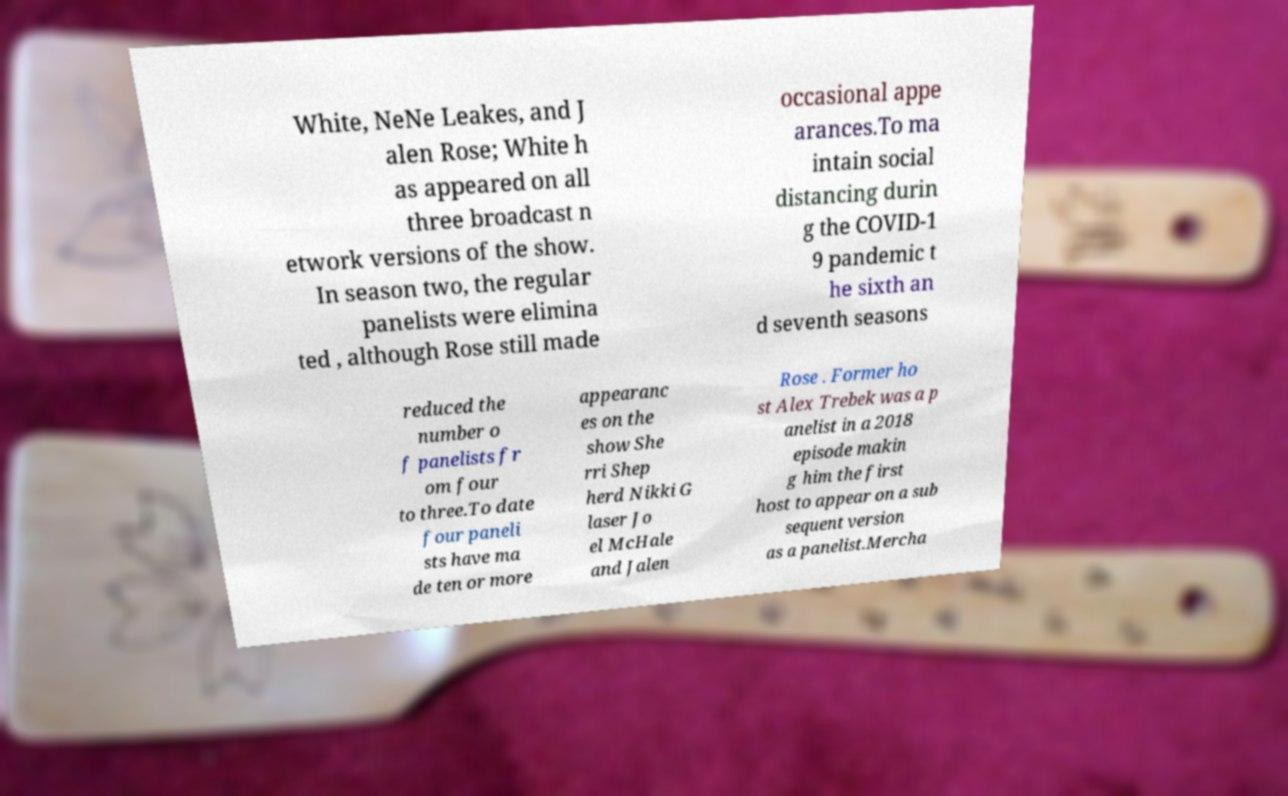Can you accurately transcribe the text from the provided image for me? White, NeNe Leakes, and J alen Rose; White h as appeared on all three broadcast n etwork versions of the show. In season two, the regular panelists were elimina ted , although Rose still made occasional appe arances.To ma intain social distancing durin g the COVID-1 9 pandemic t he sixth an d seventh seasons reduced the number o f panelists fr om four to three.To date four paneli sts have ma de ten or more appearanc es on the show She rri Shep herd Nikki G laser Jo el McHale and Jalen Rose . Former ho st Alex Trebek was a p anelist in a 2018 episode makin g him the first host to appear on a sub sequent version as a panelist.Mercha 